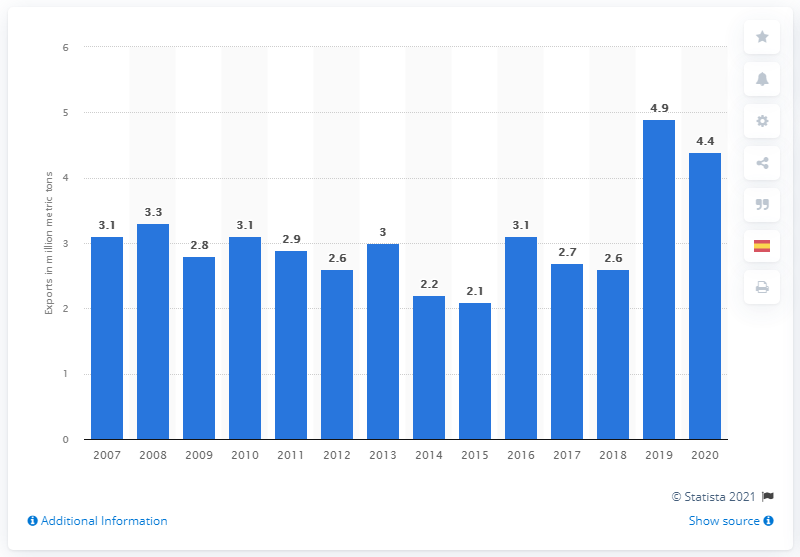Outline some significant characteristics in this image. In 2020, the total exports of steel railway track material amounted to 4.4 billion U.S. dollars. 